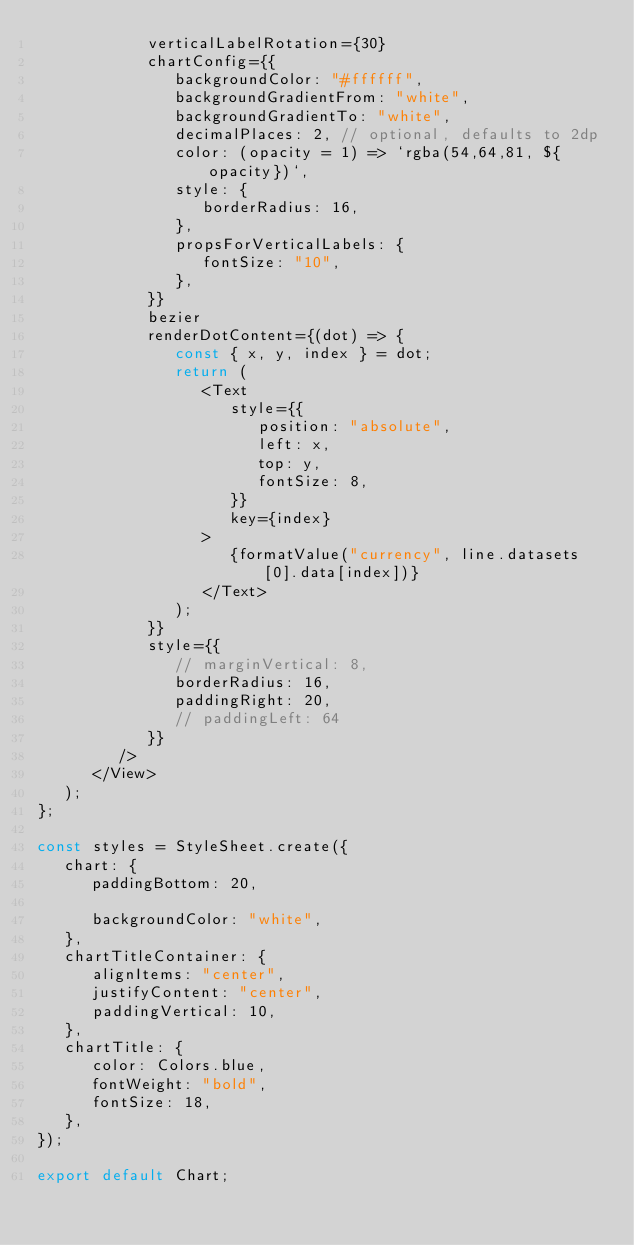<code> <loc_0><loc_0><loc_500><loc_500><_JavaScript_>            verticalLabelRotation={30}
            chartConfig={{
               backgroundColor: "#ffffff",
               backgroundGradientFrom: "white",
               backgroundGradientTo: "white",
               decimalPlaces: 2, // optional, defaults to 2dp
               color: (opacity = 1) => `rgba(54,64,81, ${opacity})`,
               style: {
                  borderRadius: 16,
               },
               propsForVerticalLabels: {
                  fontSize: "10",
               },
            }}
            bezier
            renderDotContent={(dot) => {
               const { x, y, index } = dot;
               return (
                  <Text
                     style={{
                        position: "absolute",
                        left: x,
                        top: y,
                        fontSize: 8,
                     }}
                     key={index}
                  >
                     {formatValue("currency", line.datasets[0].data[index])}
                  </Text>
               );
            }}
            style={{
               // marginVertical: 8,
               borderRadius: 16,
               paddingRight: 20,
               // paddingLeft: 64
            }}
         />
      </View>
   );
};

const styles = StyleSheet.create({
   chart: {
      paddingBottom: 20,

      backgroundColor: "white",
   },
   chartTitleContainer: {
      alignItems: "center",
      justifyContent: "center",
      paddingVertical: 10,
   },
   chartTitle: {
      color: Colors.blue,
      fontWeight: "bold",
      fontSize: 18,
   },
});

export default Chart;
</code> 